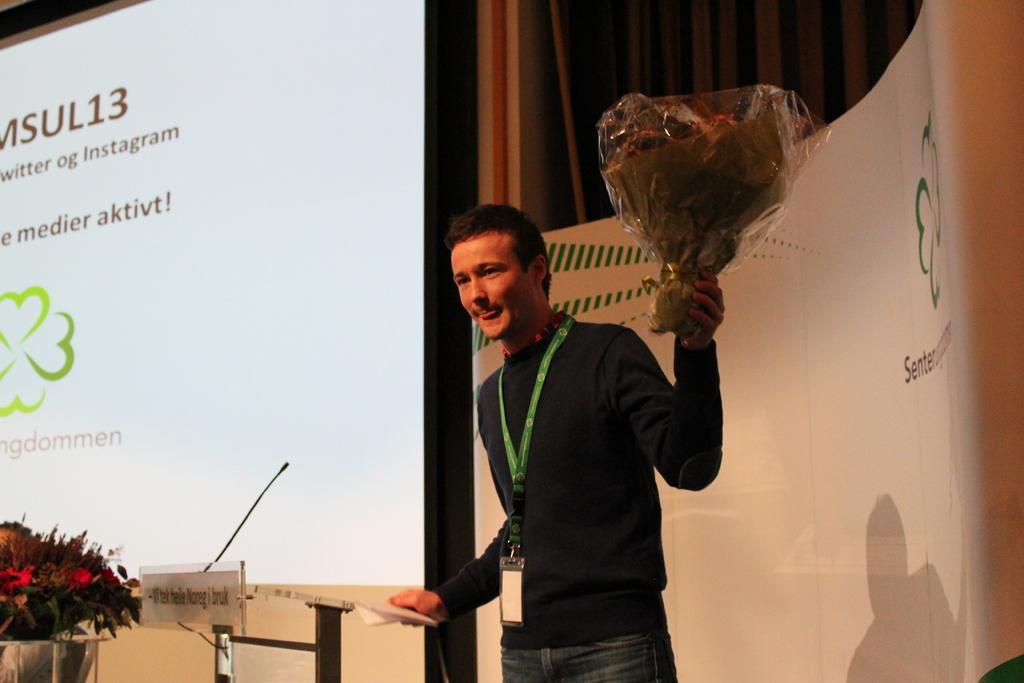How would you summarize this image in a sentence or two? In the foreground of this image, there is a man standing wearing a id card and holding a bouquet and a booklet in his hands. In the background, there is a podium with a mic, flower vase, a screen, banner and the curtain. 